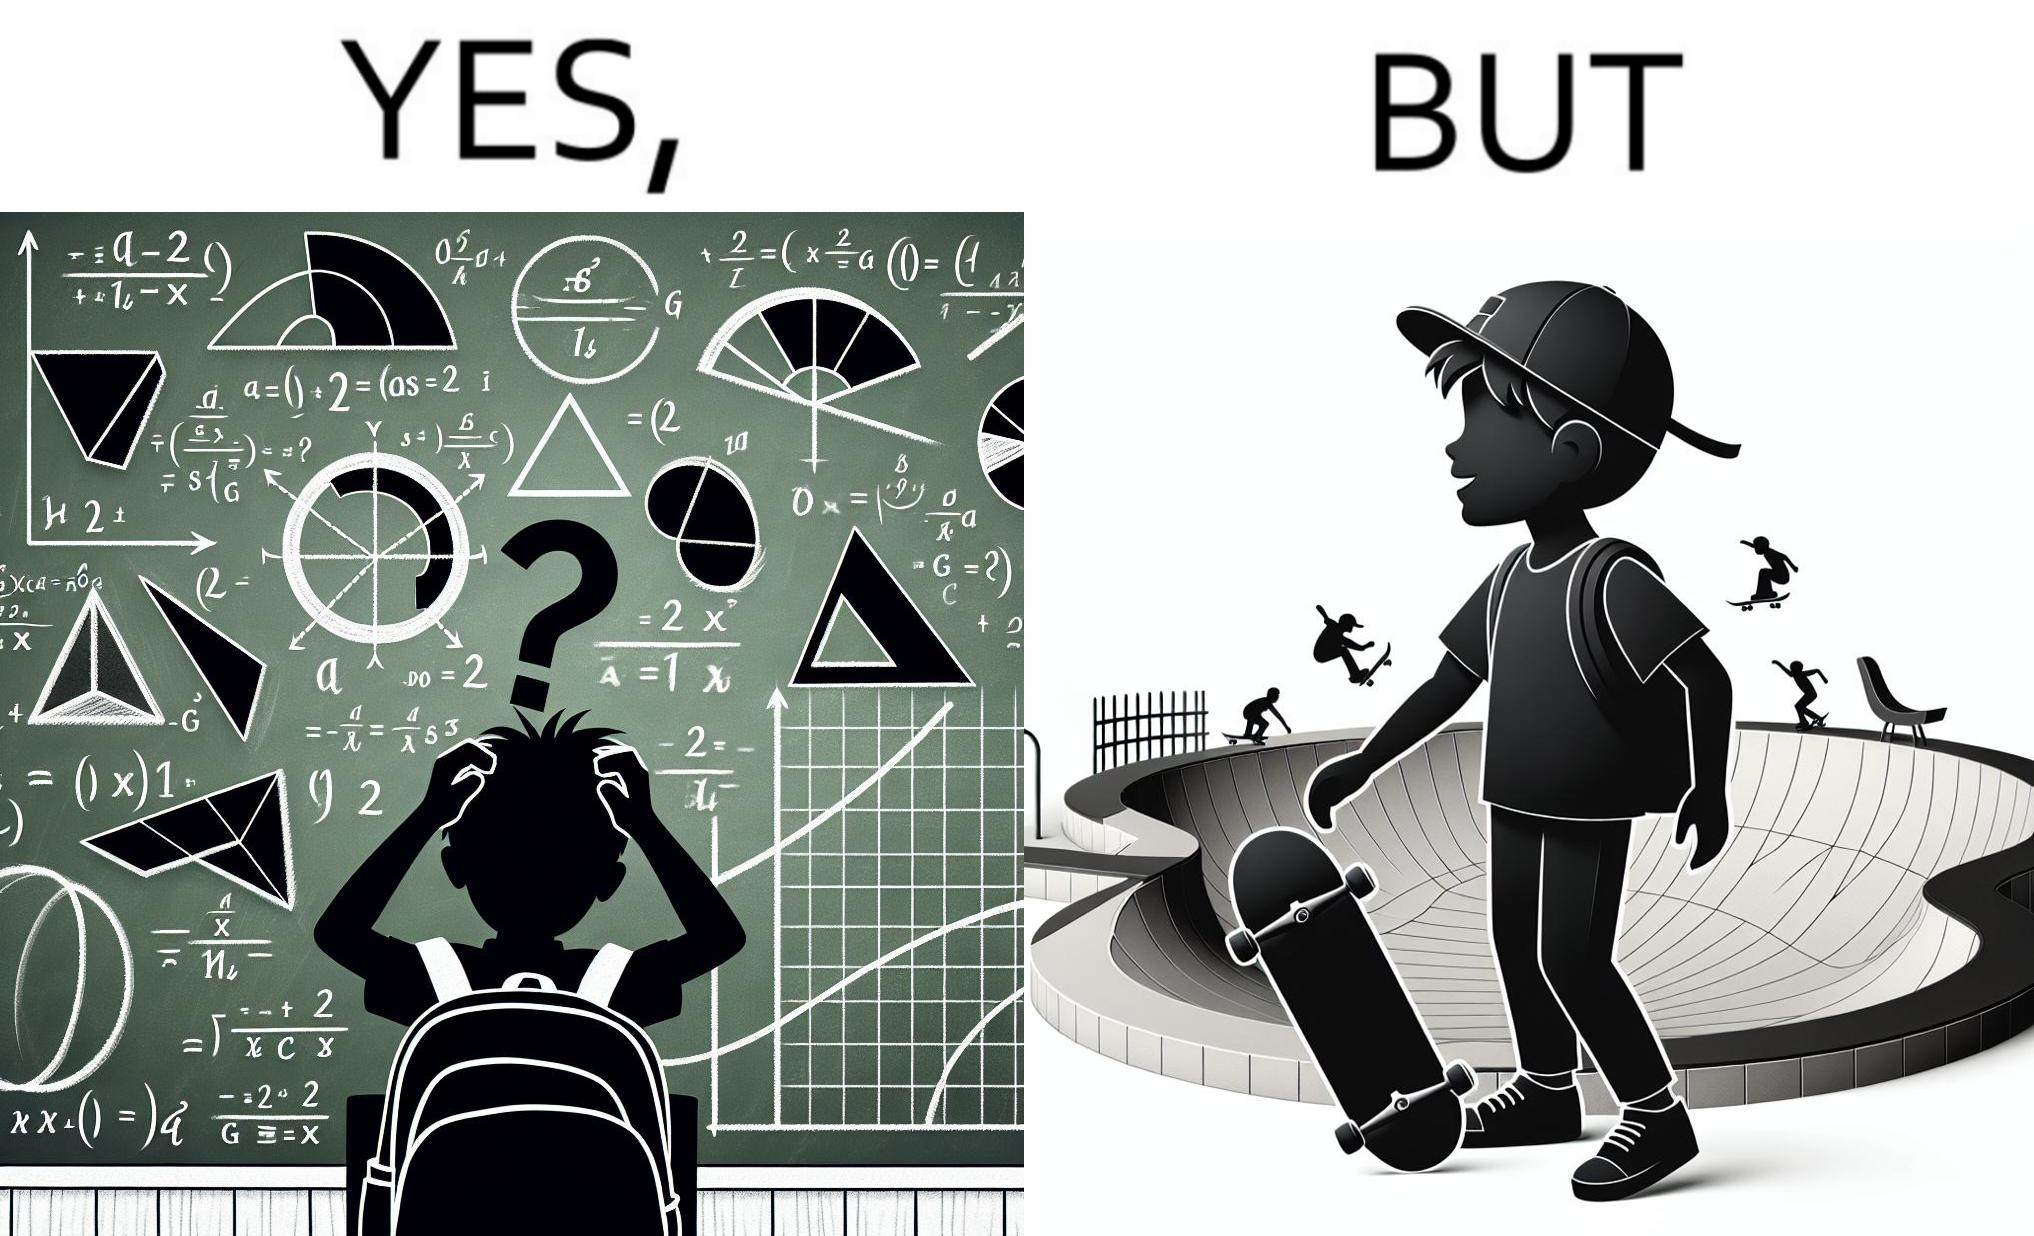What do you see in each half of this image? In the left part of the image: The image shows a boy annoyed with studying maths. Behind him is a board with lots of shapes like  semi-circle and trapezoid drawn along with mathematical formulas like areas of circle. There is a graph of sinusodial curve also drawn on the board. In the right part of the image: The image shows a boy wearing a cap with a skateboard in his hands. He is happy. In his background there is a skateboard park. In the background there is a person skateboarding on a semi cirular bowl. We also see bowls of other shapes like trapezoid and sine wave. 